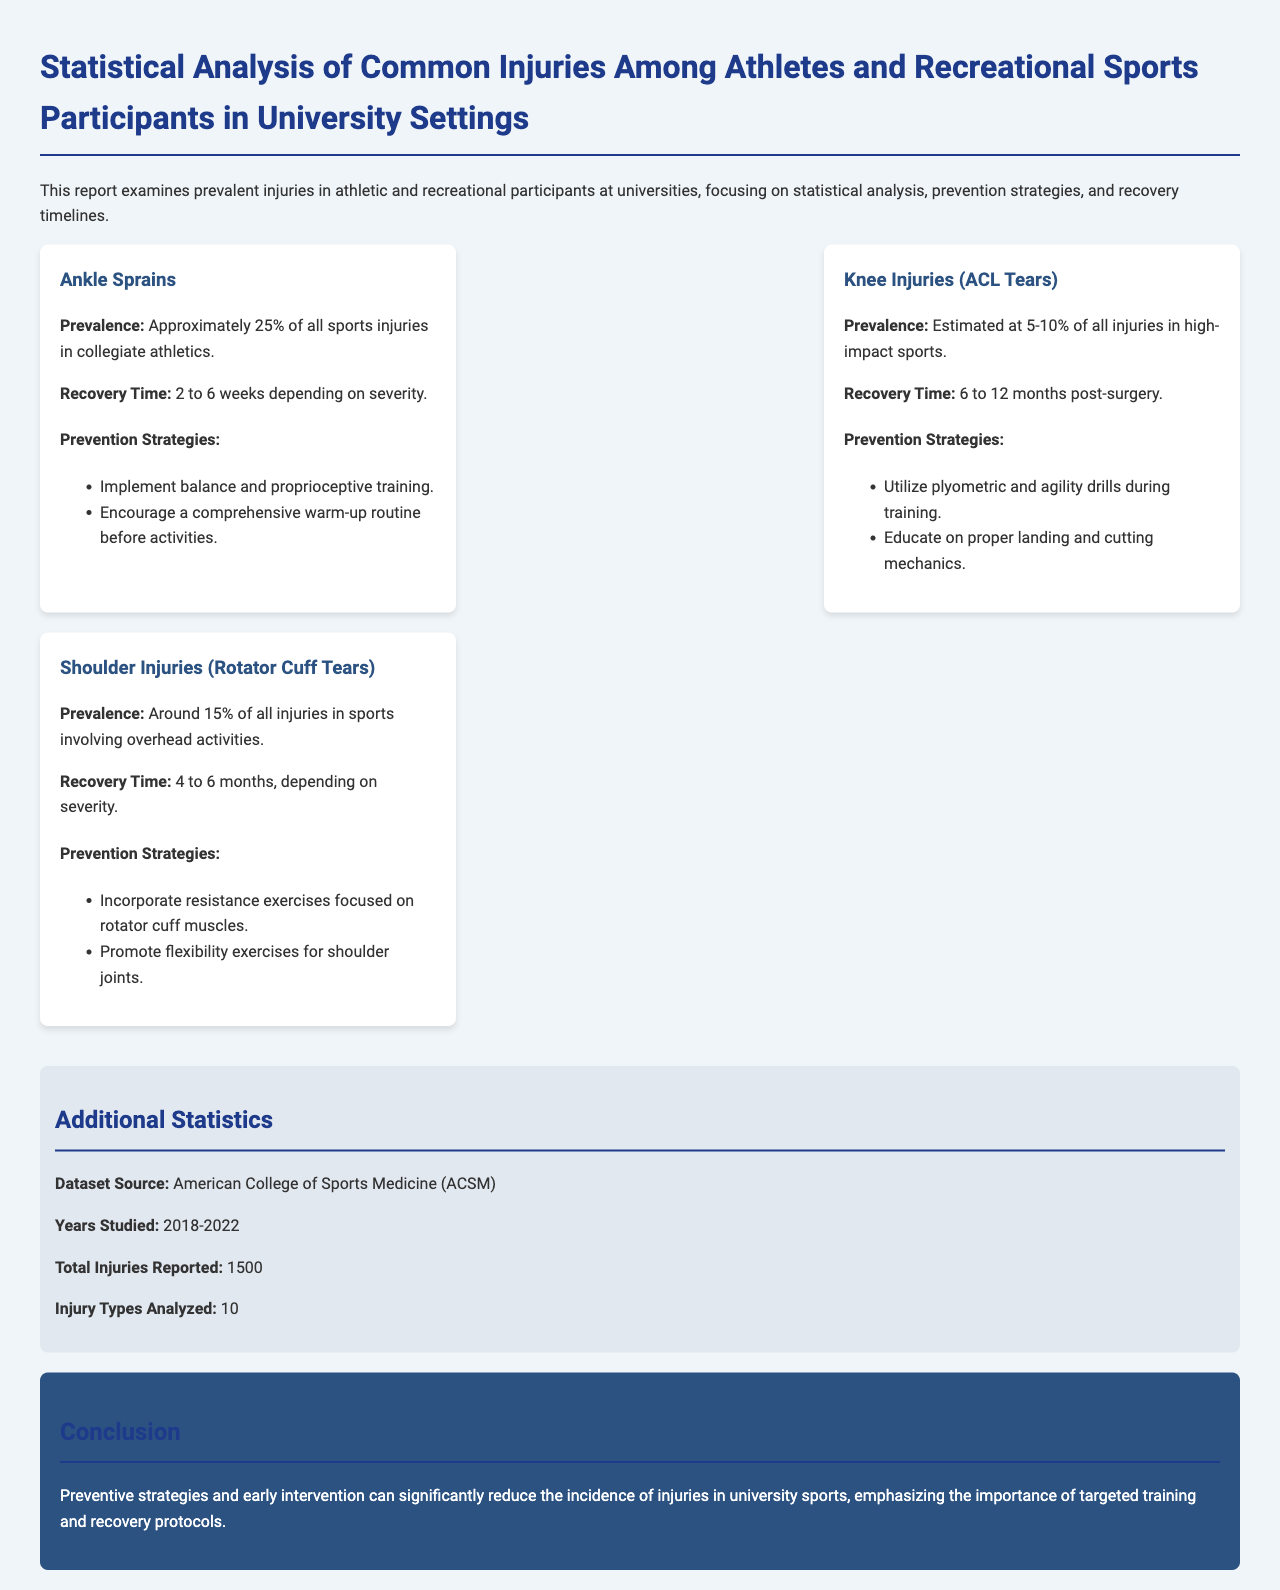What is the prevalence of ankle sprains? The prevalence of ankle sprains is stated as approximately 25% of all sports injuries in collegiate athletics.
Answer: Approximately 25% What is the recovery time for knee injuries (ACL tears)? The recovery time for knee injuries (ACL tears) is given as 6 to 12 months post-surgery.
Answer: 6 to 12 months What percentage of shoulder injuries are rotator cuff tears? The document states that shoulder injuries (rotator cuff tears) account for around 15% of all injuries in sports.
Answer: Around 15% What type of training is recommended to prevent ankle sprains? The document lists balance and proprioceptive training as a recommended prevention strategy for ankle sprains.
Answer: Balance and proprioceptive training What years were studied for the dataset? The years studied for the dataset are specified as 2018-2022.
Answer: 2018-2022 How many total injuries were reported in the study? The total injuries reported in the study are indicated as 1500.
Answer: 1500 What is highlighted as important in the conclusion regarding sports injuries? The conclusion emphasizes the importance of targeted training and recovery protocols in reducing the incidence of injuries.
Answer: Targeted training and recovery protocols What percentage of injuries are knee injuries (ACL tears) in high-impact sports? The document estimates that knee injuries (ACL tears) are 5-10% of all injuries in high-impact sports.
Answer: 5-10% What organization provided the dataset source? The dataset source is attributed to the American College of Sports Medicine (ACSM).
Answer: American College of Sports Medicine (ACSM) 